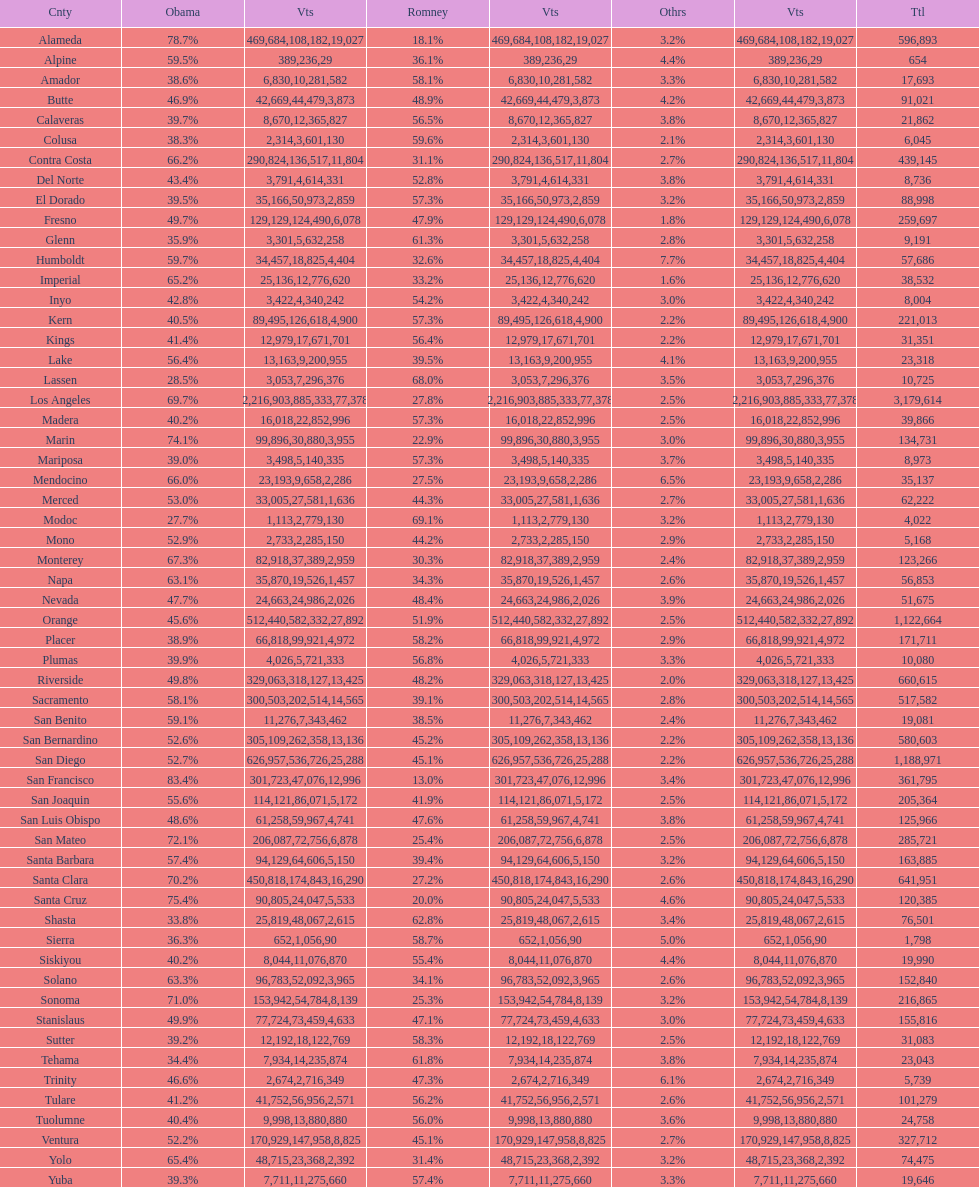What is the total number of votes for amador? 17693. 